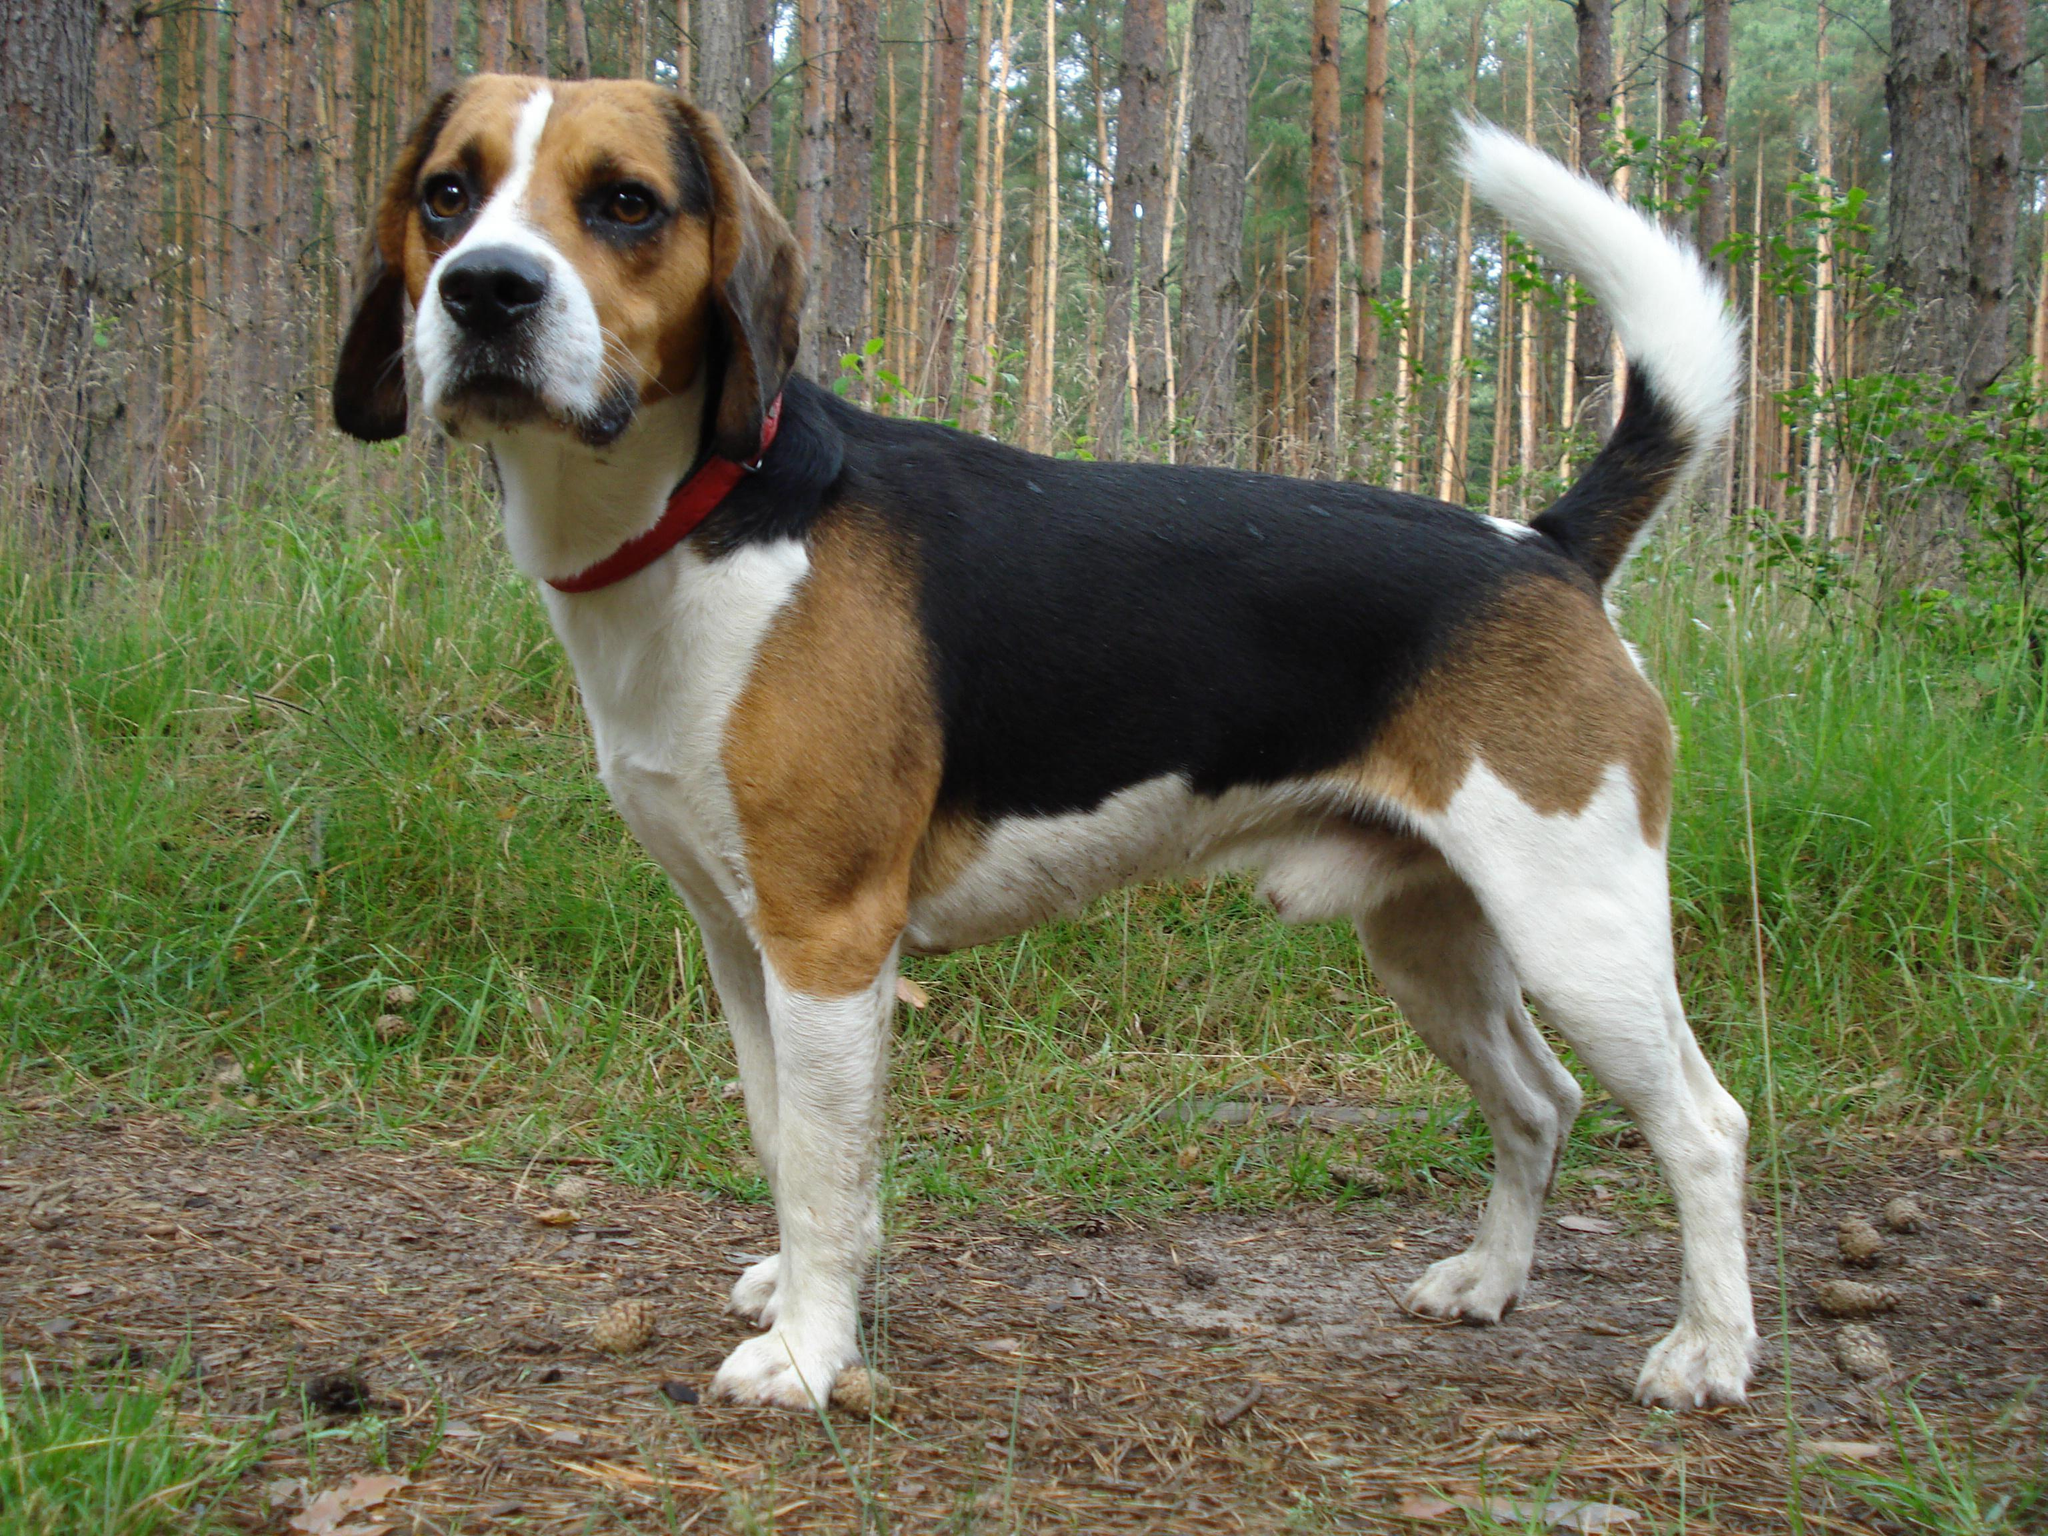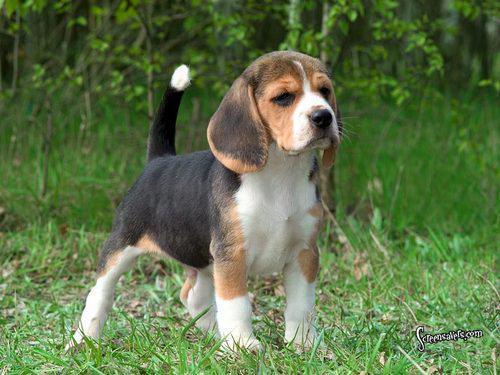The first image is the image on the left, the second image is the image on the right. Assess this claim about the two images: "In the right image the dog is facing right, and in the left image the dog is facing left.". Correct or not? Answer yes or no. Yes. 